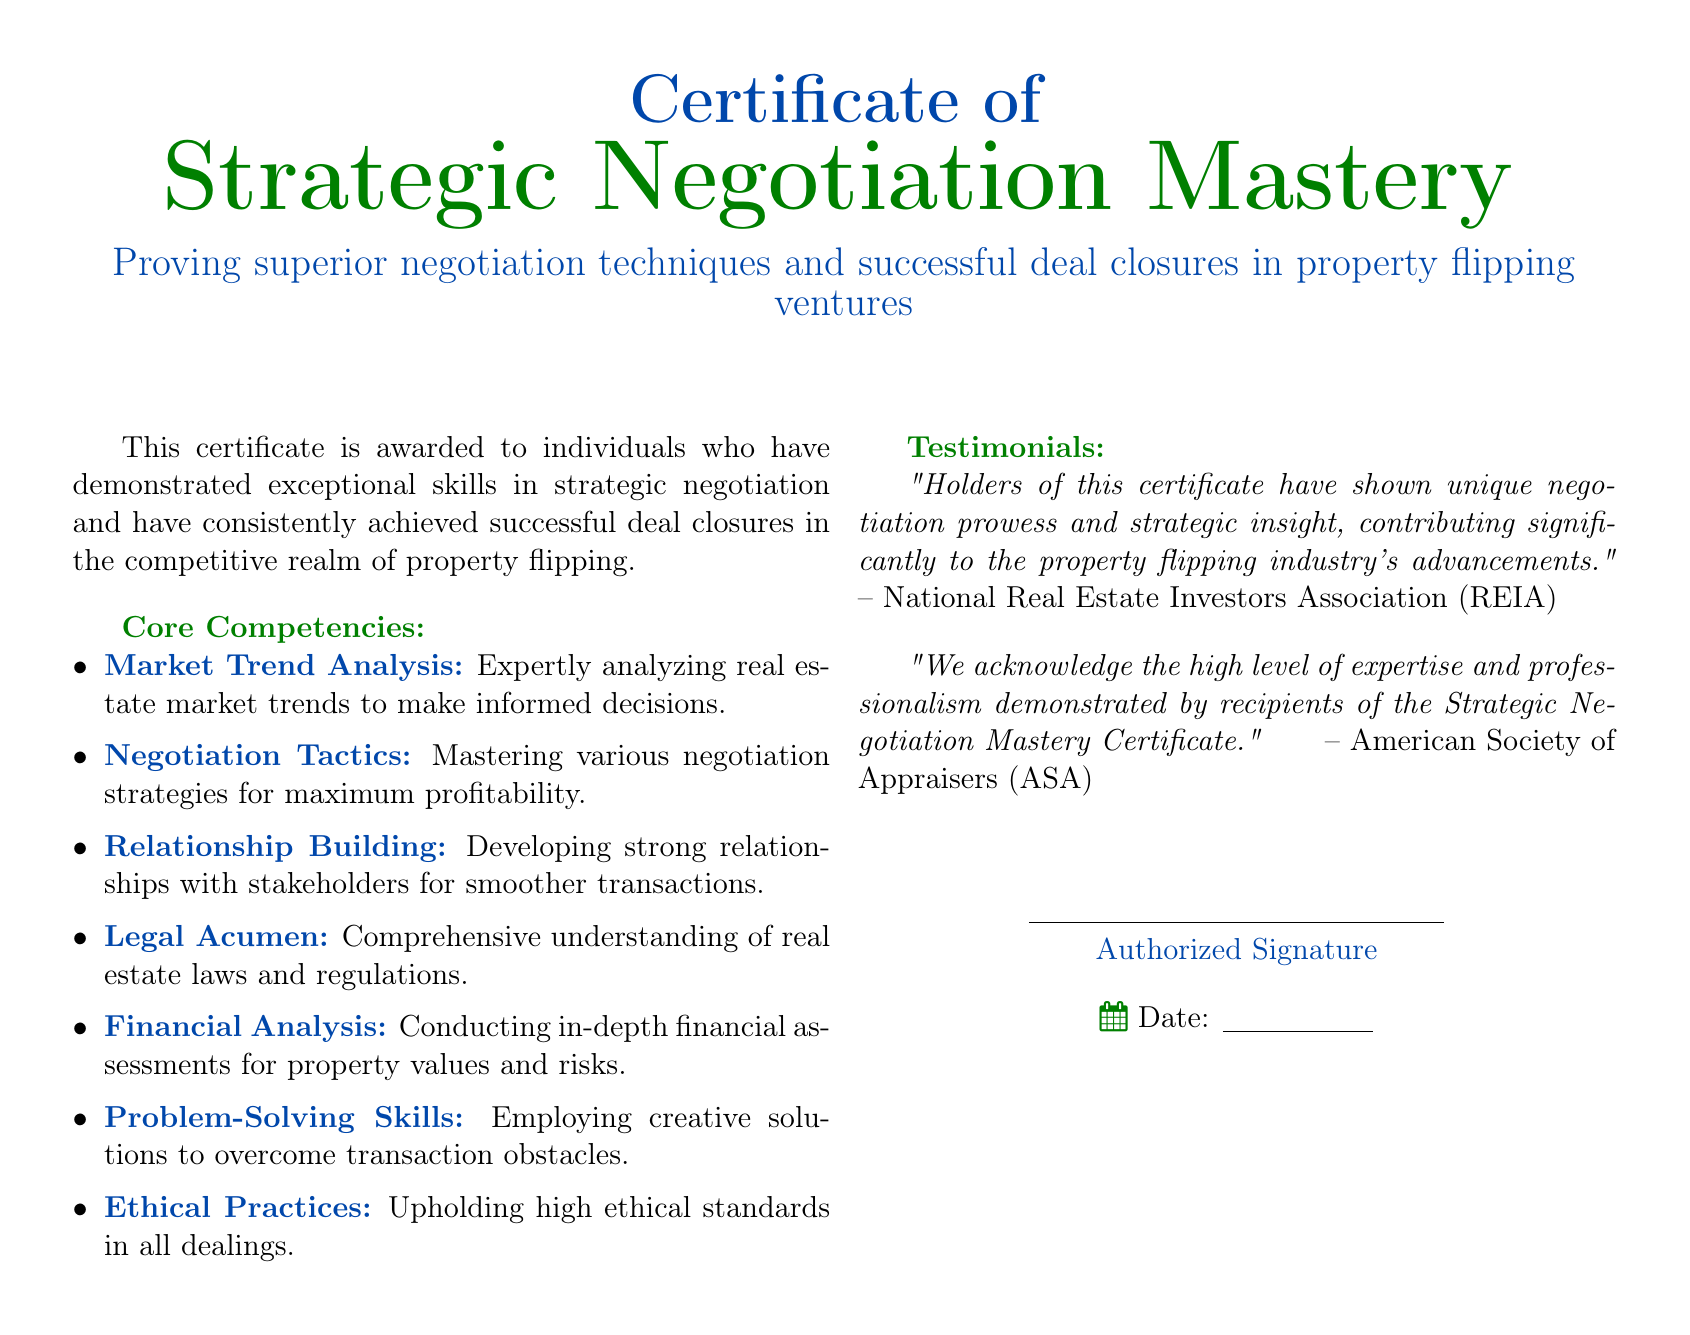What is the title of the certificate? The title is stated at the top of the document, specifically highlighting the focus on negotiation mastery.
Answer: Strategic Negotiation Mastery Who awarded the certificate? The text specifies organizations that recognize the certificate's holders, indicating their endorsement.
Answer: National Real Estate Investors Association (REIA) What are the core competencies listed in the document? The document provides specific areas of expertise relevant to the certificate, categorized into core competencies.
Answer: Market Trend Analysis, Negotiation Tactics, Relationship Building, Legal Acumen, Financial Analysis, Problem-Solving Skills, Ethical Practices What is the purpose of this certificate? The document outlines the certificate's intent, reflecting its focus on negotiation skills within property flipping.
Answer: Proving superior negotiation techniques and successful deal closures in property flipping ventures What type of organization endorsed the certificate? The document includes specific associations that recognize the certificate's significance and value.
Answer: American Society of Appraisers (ASA) 